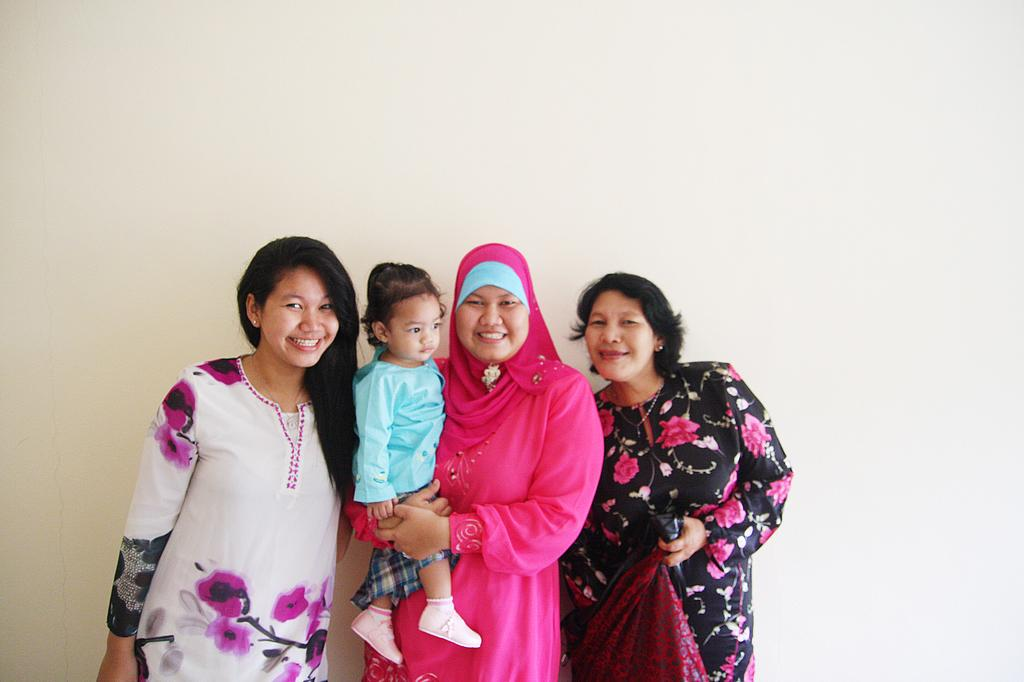How many people are in the image? There are three women in the image. What are the women doing in the image? The women are standing in front of a wall and posing for a photo. What is the middle woman holding in the image? The middle woman is holding a baby with her hands. Can you see any wounds on the baby in the image? There is no mention of any wounds in the image, and the baby's condition cannot be determined from the provided facts. 